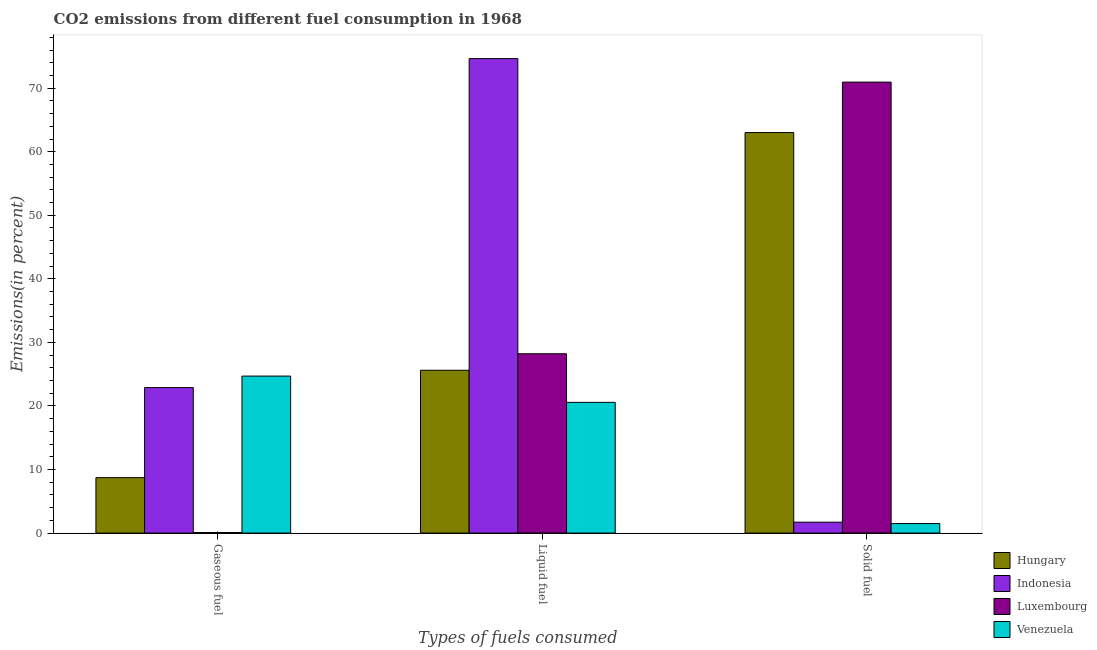Are the number of bars per tick equal to the number of legend labels?
Provide a succinct answer. Yes. Are the number of bars on each tick of the X-axis equal?
Offer a terse response. Yes. How many bars are there on the 3rd tick from the left?
Offer a very short reply. 4. How many bars are there on the 1st tick from the right?
Your answer should be very brief. 4. What is the label of the 3rd group of bars from the left?
Offer a terse response. Solid fuel. What is the percentage of liquid fuel emission in Indonesia?
Keep it short and to the point. 74.65. Across all countries, what is the maximum percentage of solid fuel emission?
Offer a very short reply. 70.95. Across all countries, what is the minimum percentage of solid fuel emission?
Provide a short and direct response. 1.5. In which country was the percentage of gaseous fuel emission minimum?
Offer a terse response. Luxembourg. What is the total percentage of liquid fuel emission in the graph?
Provide a short and direct response. 149.05. What is the difference between the percentage of gaseous fuel emission in Venezuela and that in Hungary?
Ensure brevity in your answer.  15.98. What is the difference between the percentage of gaseous fuel emission in Venezuela and the percentage of solid fuel emission in Luxembourg?
Provide a succinct answer. -46.25. What is the average percentage of liquid fuel emission per country?
Ensure brevity in your answer.  37.26. What is the difference between the percentage of solid fuel emission and percentage of liquid fuel emission in Hungary?
Provide a short and direct response. 37.4. What is the ratio of the percentage of solid fuel emission in Indonesia to that in Venezuela?
Offer a terse response. 1.15. Is the percentage of solid fuel emission in Indonesia less than that in Venezuela?
Your answer should be very brief. No. What is the difference between the highest and the second highest percentage of liquid fuel emission?
Offer a very short reply. 46.44. What is the difference between the highest and the lowest percentage of solid fuel emission?
Offer a very short reply. 69.45. Is the sum of the percentage of solid fuel emission in Hungary and Indonesia greater than the maximum percentage of gaseous fuel emission across all countries?
Offer a very short reply. Yes. What does the 4th bar from the left in Gaseous fuel represents?
Offer a very short reply. Venezuela. What does the 2nd bar from the right in Liquid fuel represents?
Your answer should be compact. Luxembourg. How many bars are there?
Provide a succinct answer. 12. How many countries are there in the graph?
Give a very brief answer. 4. Does the graph contain any zero values?
Offer a terse response. No. Does the graph contain grids?
Provide a short and direct response. No. How are the legend labels stacked?
Offer a very short reply. Vertical. What is the title of the graph?
Keep it short and to the point. CO2 emissions from different fuel consumption in 1968. Does "Burkina Faso" appear as one of the legend labels in the graph?
Make the answer very short. No. What is the label or title of the X-axis?
Provide a short and direct response. Types of fuels consumed. What is the label or title of the Y-axis?
Ensure brevity in your answer.  Emissions(in percent). What is the Emissions(in percent) in Hungary in Gaseous fuel?
Provide a short and direct response. 8.72. What is the Emissions(in percent) of Indonesia in Gaseous fuel?
Your answer should be compact. 22.89. What is the Emissions(in percent) in Luxembourg in Gaseous fuel?
Make the answer very short. 0.09. What is the Emissions(in percent) in Venezuela in Gaseous fuel?
Your response must be concise. 24.7. What is the Emissions(in percent) of Hungary in Liquid fuel?
Provide a succinct answer. 25.62. What is the Emissions(in percent) in Indonesia in Liquid fuel?
Your response must be concise. 74.65. What is the Emissions(in percent) in Luxembourg in Liquid fuel?
Your answer should be very brief. 28.21. What is the Emissions(in percent) of Venezuela in Liquid fuel?
Make the answer very short. 20.57. What is the Emissions(in percent) of Hungary in Solid fuel?
Provide a succinct answer. 63.01. What is the Emissions(in percent) in Indonesia in Solid fuel?
Keep it short and to the point. 1.71. What is the Emissions(in percent) in Luxembourg in Solid fuel?
Your answer should be compact. 70.95. What is the Emissions(in percent) in Venezuela in Solid fuel?
Provide a succinct answer. 1.5. Across all Types of fuels consumed, what is the maximum Emissions(in percent) in Hungary?
Your response must be concise. 63.01. Across all Types of fuels consumed, what is the maximum Emissions(in percent) in Indonesia?
Your answer should be very brief. 74.65. Across all Types of fuels consumed, what is the maximum Emissions(in percent) of Luxembourg?
Offer a terse response. 70.95. Across all Types of fuels consumed, what is the maximum Emissions(in percent) in Venezuela?
Offer a terse response. 24.7. Across all Types of fuels consumed, what is the minimum Emissions(in percent) in Hungary?
Your answer should be compact. 8.72. Across all Types of fuels consumed, what is the minimum Emissions(in percent) in Indonesia?
Your answer should be very brief. 1.71. Across all Types of fuels consumed, what is the minimum Emissions(in percent) of Luxembourg?
Ensure brevity in your answer.  0.09. Across all Types of fuels consumed, what is the minimum Emissions(in percent) in Venezuela?
Your answer should be compact. 1.5. What is the total Emissions(in percent) of Hungary in the graph?
Make the answer very short. 97.35. What is the total Emissions(in percent) in Indonesia in the graph?
Provide a short and direct response. 99.26. What is the total Emissions(in percent) in Luxembourg in the graph?
Make the answer very short. 99.25. What is the total Emissions(in percent) of Venezuela in the graph?
Your answer should be compact. 46.76. What is the difference between the Emissions(in percent) in Hungary in Gaseous fuel and that in Liquid fuel?
Offer a terse response. -16.9. What is the difference between the Emissions(in percent) of Indonesia in Gaseous fuel and that in Liquid fuel?
Offer a very short reply. -51.76. What is the difference between the Emissions(in percent) in Luxembourg in Gaseous fuel and that in Liquid fuel?
Your response must be concise. -28.12. What is the difference between the Emissions(in percent) of Venezuela in Gaseous fuel and that in Liquid fuel?
Keep it short and to the point. 4.13. What is the difference between the Emissions(in percent) in Hungary in Gaseous fuel and that in Solid fuel?
Offer a terse response. -54.3. What is the difference between the Emissions(in percent) in Indonesia in Gaseous fuel and that in Solid fuel?
Provide a succinct answer. 21.18. What is the difference between the Emissions(in percent) in Luxembourg in Gaseous fuel and that in Solid fuel?
Keep it short and to the point. -70.86. What is the difference between the Emissions(in percent) of Venezuela in Gaseous fuel and that in Solid fuel?
Provide a short and direct response. 23.2. What is the difference between the Emissions(in percent) of Hungary in Liquid fuel and that in Solid fuel?
Ensure brevity in your answer.  -37.4. What is the difference between the Emissions(in percent) in Indonesia in Liquid fuel and that in Solid fuel?
Your answer should be compact. 72.94. What is the difference between the Emissions(in percent) of Luxembourg in Liquid fuel and that in Solid fuel?
Provide a succinct answer. -42.74. What is the difference between the Emissions(in percent) of Venezuela in Liquid fuel and that in Solid fuel?
Provide a succinct answer. 19.07. What is the difference between the Emissions(in percent) of Hungary in Gaseous fuel and the Emissions(in percent) of Indonesia in Liquid fuel?
Ensure brevity in your answer.  -65.93. What is the difference between the Emissions(in percent) in Hungary in Gaseous fuel and the Emissions(in percent) in Luxembourg in Liquid fuel?
Provide a short and direct response. -19.49. What is the difference between the Emissions(in percent) of Hungary in Gaseous fuel and the Emissions(in percent) of Venezuela in Liquid fuel?
Ensure brevity in your answer.  -11.85. What is the difference between the Emissions(in percent) of Indonesia in Gaseous fuel and the Emissions(in percent) of Luxembourg in Liquid fuel?
Give a very brief answer. -5.32. What is the difference between the Emissions(in percent) in Indonesia in Gaseous fuel and the Emissions(in percent) in Venezuela in Liquid fuel?
Your response must be concise. 2.32. What is the difference between the Emissions(in percent) in Luxembourg in Gaseous fuel and the Emissions(in percent) in Venezuela in Liquid fuel?
Provide a short and direct response. -20.48. What is the difference between the Emissions(in percent) in Hungary in Gaseous fuel and the Emissions(in percent) in Indonesia in Solid fuel?
Offer a terse response. 7. What is the difference between the Emissions(in percent) in Hungary in Gaseous fuel and the Emissions(in percent) in Luxembourg in Solid fuel?
Provide a succinct answer. -62.23. What is the difference between the Emissions(in percent) of Hungary in Gaseous fuel and the Emissions(in percent) of Venezuela in Solid fuel?
Provide a succinct answer. 7.22. What is the difference between the Emissions(in percent) of Indonesia in Gaseous fuel and the Emissions(in percent) of Luxembourg in Solid fuel?
Ensure brevity in your answer.  -48.06. What is the difference between the Emissions(in percent) of Indonesia in Gaseous fuel and the Emissions(in percent) of Venezuela in Solid fuel?
Offer a terse response. 21.39. What is the difference between the Emissions(in percent) of Luxembourg in Gaseous fuel and the Emissions(in percent) of Venezuela in Solid fuel?
Keep it short and to the point. -1.41. What is the difference between the Emissions(in percent) of Hungary in Liquid fuel and the Emissions(in percent) of Indonesia in Solid fuel?
Ensure brevity in your answer.  23.9. What is the difference between the Emissions(in percent) of Hungary in Liquid fuel and the Emissions(in percent) of Luxembourg in Solid fuel?
Make the answer very short. -45.33. What is the difference between the Emissions(in percent) in Hungary in Liquid fuel and the Emissions(in percent) in Venezuela in Solid fuel?
Your answer should be very brief. 24.12. What is the difference between the Emissions(in percent) of Indonesia in Liquid fuel and the Emissions(in percent) of Luxembourg in Solid fuel?
Your response must be concise. 3.7. What is the difference between the Emissions(in percent) of Indonesia in Liquid fuel and the Emissions(in percent) of Venezuela in Solid fuel?
Your response must be concise. 73.15. What is the difference between the Emissions(in percent) in Luxembourg in Liquid fuel and the Emissions(in percent) in Venezuela in Solid fuel?
Provide a succinct answer. 26.72. What is the average Emissions(in percent) of Hungary per Types of fuels consumed?
Ensure brevity in your answer.  32.45. What is the average Emissions(in percent) of Indonesia per Types of fuels consumed?
Offer a terse response. 33.09. What is the average Emissions(in percent) in Luxembourg per Types of fuels consumed?
Your answer should be compact. 33.08. What is the average Emissions(in percent) of Venezuela per Types of fuels consumed?
Offer a very short reply. 15.59. What is the difference between the Emissions(in percent) of Hungary and Emissions(in percent) of Indonesia in Gaseous fuel?
Make the answer very short. -14.17. What is the difference between the Emissions(in percent) of Hungary and Emissions(in percent) of Luxembourg in Gaseous fuel?
Your response must be concise. 8.63. What is the difference between the Emissions(in percent) of Hungary and Emissions(in percent) of Venezuela in Gaseous fuel?
Your response must be concise. -15.98. What is the difference between the Emissions(in percent) of Indonesia and Emissions(in percent) of Luxembourg in Gaseous fuel?
Your response must be concise. 22.8. What is the difference between the Emissions(in percent) of Indonesia and Emissions(in percent) of Venezuela in Gaseous fuel?
Make the answer very short. -1.81. What is the difference between the Emissions(in percent) of Luxembourg and Emissions(in percent) of Venezuela in Gaseous fuel?
Offer a very short reply. -24.61. What is the difference between the Emissions(in percent) of Hungary and Emissions(in percent) of Indonesia in Liquid fuel?
Offer a very short reply. -49.03. What is the difference between the Emissions(in percent) of Hungary and Emissions(in percent) of Luxembourg in Liquid fuel?
Provide a succinct answer. -2.6. What is the difference between the Emissions(in percent) in Hungary and Emissions(in percent) in Venezuela in Liquid fuel?
Offer a very short reply. 5.05. What is the difference between the Emissions(in percent) of Indonesia and Emissions(in percent) of Luxembourg in Liquid fuel?
Your response must be concise. 46.44. What is the difference between the Emissions(in percent) in Indonesia and Emissions(in percent) in Venezuela in Liquid fuel?
Your answer should be very brief. 54.09. What is the difference between the Emissions(in percent) in Luxembourg and Emissions(in percent) in Venezuela in Liquid fuel?
Provide a succinct answer. 7.65. What is the difference between the Emissions(in percent) of Hungary and Emissions(in percent) of Indonesia in Solid fuel?
Your answer should be compact. 61.3. What is the difference between the Emissions(in percent) in Hungary and Emissions(in percent) in Luxembourg in Solid fuel?
Keep it short and to the point. -7.94. What is the difference between the Emissions(in percent) of Hungary and Emissions(in percent) of Venezuela in Solid fuel?
Provide a short and direct response. 61.52. What is the difference between the Emissions(in percent) in Indonesia and Emissions(in percent) in Luxembourg in Solid fuel?
Ensure brevity in your answer.  -69.24. What is the difference between the Emissions(in percent) of Indonesia and Emissions(in percent) of Venezuela in Solid fuel?
Your answer should be compact. 0.22. What is the difference between the Emissions(in percent) in Luxembourg and Emissions(in percent) in Venezuela in Solid fuel?
Offer a very short reply. 69.45. What is the ratio of the Emissions(in percent) in Hungary in Gaseous fuel to that in Liquid fuel?
Ensure brevity in your answer.  0.34. What is the ratio of the Emissions(in percent) in Indonesia in Gaseous fuel to that in Liquid fuel?
Offer a terse response. 0.31. What is the ratio of the Emissions(in percent) in Luxembourg in Gaseous fuel to that in Liquid fuel?
Provide a succinct answer. 0. What is the ratio of the Emissions(in percent) in Venezuela in Gaseous fuel to that in Liquid fuel?
Offer a very short reply. 1.2. What is the ratio of the Emissions(in percent) of Hungary in Gaseous fuel to that in Solid fuel?
Make the answer very short. 0.14. What is the ratio of the Emissions(in percent) of Indonesia in Gaseous fuel to that in Solid fuel?
Your response must be concise. 13.35. What is the ratio of the Emissions(in percent) in Luxembourg in Gaseous fuel to that in Solid fuel?
Provide a succinct answer. 0. What is the ratio of the Emissions(in percent) of Venezuela in Gaseous fuel to that in Solid fuel?
Offer a terse response. 16.5. What is the ratio of the Emissions(in percent) of Hungary in Liquid fuel to that in Solid fuel?
Give a very brief answer. 0.41. What is the ratio of the Emissions(in percent) of Indonesia in Liquid fuel to that in Solid fuel?
Provide a short and direct response. 43.53. What is the ratio of the Emissions(in percent) of Luxembourg in Liquid fuel to that in Solid fuel?
Make the answer very short. 0.4. What is the ratio of the Emissions(in percent) in Venezuela in Liquid fuel to that in Solid fuel?
Your answer should be compact. 13.74. What is the difference between the highest and the second highest Emissions(in percent) in Hungary?
Offer a very short reply. 37.4. What is the difference between the highest and the second highest Emissions(in percent) in Indonesia?
Provide a succinct answer. 51.76. What is the difference between the highest and the second highest Emissions(in percent) in Luxembourg?
Your response must be concise. 42.74. What is the difference between the highest and the second highest Emissions(in percent) of Venezuela?
Ensure brevity in your answer.  4.13. What is the difference between the highest and the lowest Emissions(in percent) in Hungary?
Make the answer very short. 54.3. What is the difference between the highest and the lowest Emissions(in percent) of Indonesia?
Give a very brief answer. 72.94. What is the difference between the highest and the lowest Emissions(in percent) in Luxembourg?
Provide a short and direct response. 70.86. What is the difference between the highest and the lowest Emissions(in percent) of Venezuela?
Provide a short and direct response. 23.2. 